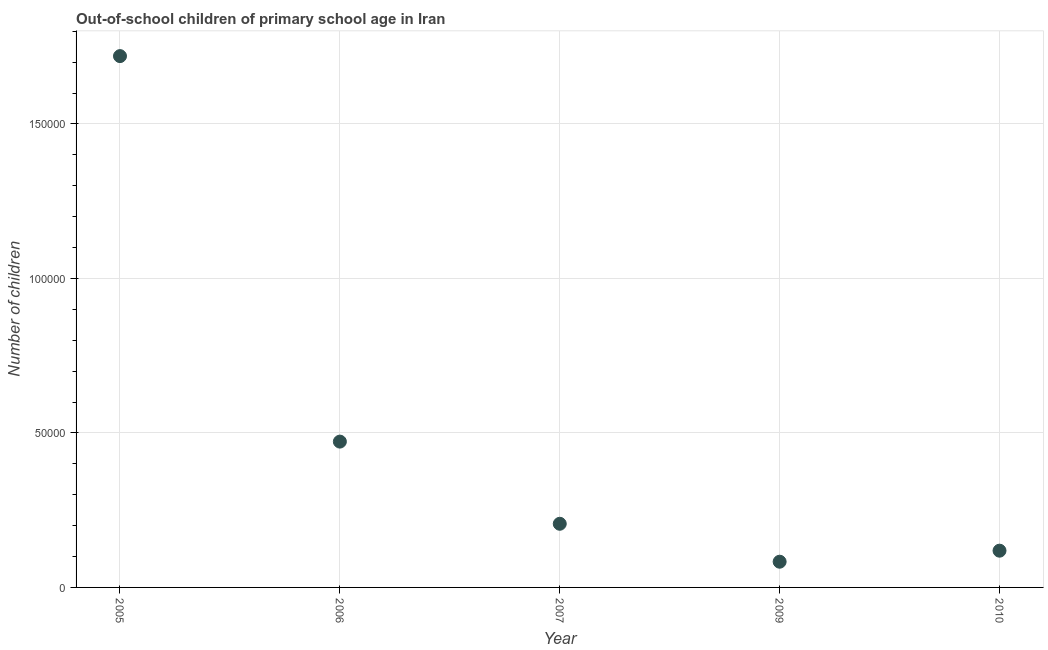What is the number of out-of-school children in 2009?
Your response must be concise. 8322. Across all years, what is the maximum number of out-of-school children?
Your answer should be compact. 1.72e+05. Across all years, what is the minimum number of out-of-school children?
Ensure brevity in your answer.  8322. In which year was the number of out-of-school children minimum?
Your response must be concise. 2009. What is the sum of the number of out-of-school children?
Provide a short and direct response. 2.60e+05. What is the difference between the number of out-of-school children in 2006 and 2010?
Your answer should be compact. 3.53e+04. What is the average number of out-of-school children per year?
Offer a very short reply. 5.20e+04. What is the median number of out-of-school children?
Your answer should be very brief. 2.06e+04. Do a majority of the years between 2006 and 2010 (inclusive) have number of out-of-school children greater than 10000 ?
Keep it short and to the point. Yes. What is the ratio of the number of out-of-school children in 2007 to that in 2010?
Provide a short and direct response. 1.73. Is the difference between the number of out-of-school children in 2006 and 2010 greater than the difference between any two years?
Your answer should be compact. No. What is the difference between the highest and the second highest number of out-of-school children?
Provide a succinct answer. 1.25e+05. What is the difference between the highest and the lowest number of out-of-school children?
Make the answer very short. 1.64e+05. Does the number of out-of-school children monotonically increase over the years?
Provide a short and direct response. No. Does the graph contain any zero values?
Provide a succinct answer. No. What is the title of the graph?
Keep it short and to the point. Out-of-school children of primary school age in Iran. What is the label or title of the X-axis?
Your response must be concise. Year. What is the label or title of the Y-axis?
Your answer should be compact. Number of children. What is the Number of children in 2005?
Provide a short and direct response. 1.72e+05. What is the Number of children in 2006?
Keep it short and to the point. 4.72e+04. What is the Number of children in 2007?
Your answer should be compact. 2.06e+04. What is the Number of children in 2009?
Make the answer very short. 8322. What is the Number of children in 2010?
Keep it short and to the point. 1.19e+04. What is the difference between the Number of children in 2005 and 2006?
Ensure brevity in your answer.  1.25e+05. What is the difference between the Number of children in 2005 and 2007?
Provide a succinct answer. 1.51e+05. What is the difference between the Number of children in 2005 and 2009?
Give a very brief answer. 1.64e+05. What is the difference between the Number of children in 2005 and 2010?
Your response must be concise. 1.60e+05. What is the difference between the Number of children in 2006 and 2007?
Provide a succinct answer. 2.66e+04. What is the difference between the Number of children in 2006 and 2009?
Provide a succinct answer. 3.89e+04. What is the difference between the Number of children in 2006 and 2010?
Offer a very short reply. 3.53e+04. What is the difference between the Number of children in 2007 and 2009?
Your response must be concise. 1.23e+04. What is the difference between the Number of children in 2007 and 2010?
Your response must be concise. 8710. What is the difference between the Number of children in 2009 and 2010?
Provide a short and direct response. -3569. What is the ratio of the Number of children in 2005 to that in 2006?
Provide a short and direct response. 3.64. What is the ratio of the Number of children in 2005 to that in 2007?
Keep it short and to the point. 8.35. What is the ratio of the Number of children in 2005 to that in 2009?
Offer a terse response. 20.66. What is the ratio of the Number of children in 2005 to that in 2010?
Make the answer very short. 14.46. What is the ratio of the Number of children in 2006 to that in 2007?
Offer a very short reply. 2.29. What is the ratio of the Number of children in 2006 to that in 2009?
Offer a very short reply. 5.67. What is the ratio of the Number of children in 2006 to that in 2010?
Offer a very short reply. 3.97. What is the ratio of the Number of children in 2007 to that in 2009?
Offer a terse response. 2.48. What is the ratio of the Number of children in 2007 to that in 2010?
Make the answer very short. 1.73. 